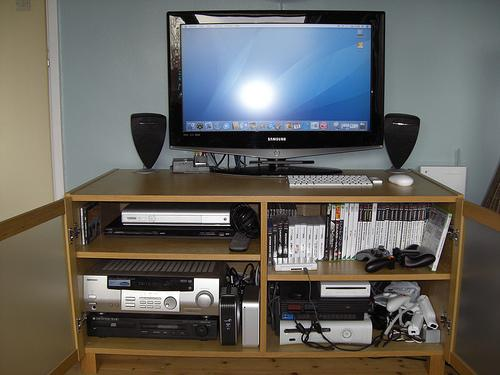Detail the various gaming equipment and accessories present in the image. There are video games, game consoles, remote controls, two black Xbox controllers, a Wii game system, a white Xbox controller, and a white Wii controller. Explain the arrangement of speakers in relation to the screen. There are two speakers, one on each side of the screen. What type of computer equipment can be found in the image? An Apple Mac Mini computer, an Apple wireless computer keyboard, and a white Apple Magic Mouse are present in the image. What type of sound system is present in the image? There is a stereo on the shelf and two black speakers on each side of the screen. How many game controllers are there, and what types are they? There are 6 game controllers - two black Xbox controllers, a white Xbox controller, two Wii controllers, and a white Wii game system controller. Please describe the wall color and furniture on which the TV and other devices are placed. The wall is blue painted, and the TV and other devices are placed on a wooden entertainment center. Analyze the sentiment of this image setup. The image setup displays a cozy and engaging entertainment system with a variety of gaming and electronic equipment, appealing to individuals who enjoy technology and home entertainment. Identify the items placed on the shelf below the TV. A silver DVD player, a stereo, a router, a game console, and remote controls are placed on the shelf below the TV. Count the number of DVD objects found on the top shelf. There are 7 DVDs on the top shelf. Identify the type of electronic device placed in the center of the image. A large flatscreen TV is placed in the center of the image. Is the wooden entertainment center placed in the upper-left corner of the image? The wooden entertainment center is not in the upper-left corner, as its given X and Y position is 66 and 168, respectively. Identify and specify the location of the two speakers in the image. black speaker next to tv (X:125 Y:111 Width:40 Height:40), speaker on side of tv (X:374 Y:109 Width:47 Height:47) Are all the DVD's on the top shelf placed tightly together without any gaps? The DVD's on the top shelf might not be placed tightly together without gaps, as their given X positions indicate that some DVDs are separated from each other. For example, one DVD is at X position 340 while another is at X position 429. Are there any anomalies or out of place objects in the image? no anomalies Identify the remote controls found within the image. white Apple remote, white Wii controller What is the overall sentiment or emotion evoked by the image? neutral What material is the entertainment center made of? wood How many game controllers are in the image? 6 Rate the image quality from 1 to 5, with 5 being the highest. 5 How many DVDs are on the top shelf? 7 Which gaming consoles are present in the image? white Wii game system, white Xbox 360, black PlayStation Describe the interaction between the Wiimote controller and the black game controllers. The white Wii controller is on the shelf across from the black controllers. Does the blue painted wall on the image cover the entire background? The blue painted wall does not cover the entire background, as its given Width and Height are 436 and 436, respectively, which may not be the full dimensions of the image. Identify any visible text or characters in the image. no visible text Is there only one black controller on the wooden shelf with video games? There are two black controllers on the wooden shelf with video games, as mentioned in the given information. What is the brand of the computer keyboard? Apple Are the stereo stand doors open or closed in the image? open Specify the objects at the coordinates X:371 Y:285 a white Xbox controller What is the dominant color in the background of the image? blue Describe the primary components of the image. wooden entertainment center, large flatscreen tv, speakers, wooden shelf with video games, game console List the games for the game console in the image. row of video games (X:268 Y:204 Width:175 Height:175) Are the black speaker and white keyboard placed on top of the large flatscreen tv? The black speaker and white keyboard are not placed on top of the large flatscreen tv, as their given Y positions are 111 and 171 respectively, which are below the large flatscreen tv Y position of 6. Is the screen of the large flatscreen tv on or off? on What type of device is on the shelf at X:237 Y:299? an Apple Mac Mini computer Is there a large flatscreen tv placed on the right side of the entertainment center? The large flatscreen tv is not placed on the right side of the entertainment center. According to its coordinates, it is placed within the wooden entertainment center. 